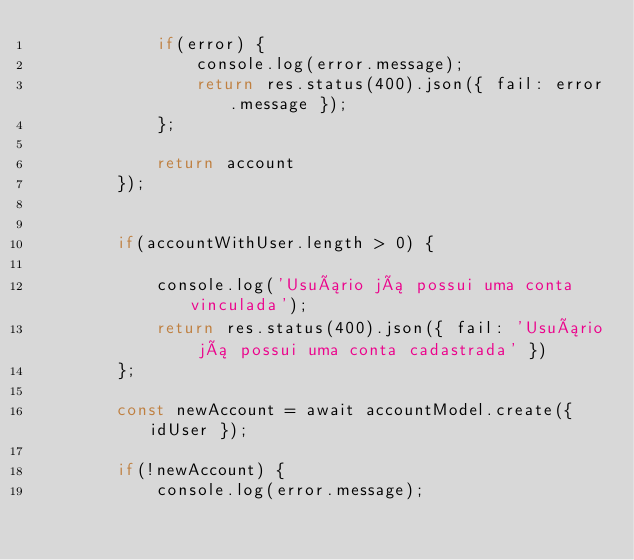Convert code to text. <code><loc_0><loc_0><loc_500><loc_500><_JavaScript_>            if(error) {
                console.log(error.message);
                return res.status(400).json({ fail: error.message });
            };

            return account
        });

        
        if(accountWithUser.length > 0) {
             
            console.log('Usuário já possui uma conta vinculada');
            return res.status(400).json({ fail: 'Usuário já possui uma conta cadastrada' })
        };
    
        const newAccount = await accountModel.create({ idUser });
        
        if(!newAccount) {
            console.log(error.message);</code> 